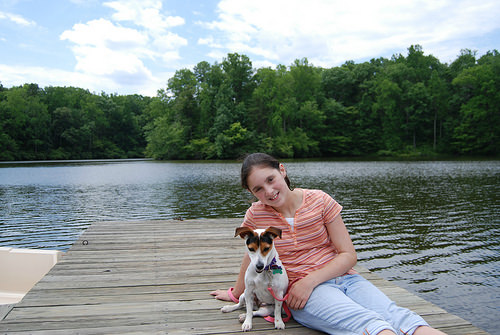<image>
Is there a dog in front of the water? Yes. The dog is positioned in front of the water, appearing closer to the camera viewpoint. 